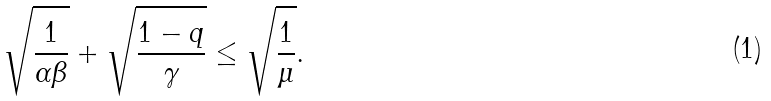Convert formula to latex. <formula><loc_0><loc_0><loc_500><loc_500>\sqrt { \frac { 1 } { \alpha \beta } } + \sqrt { \frac { 1 - q } { \gamma } } \leq \sqrt { \frac { 1 } { \mu } } .</formula> 